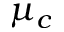<formula> <loc_0><loc_0><loc_500><loc_500>\mu _ { c }</formula> 